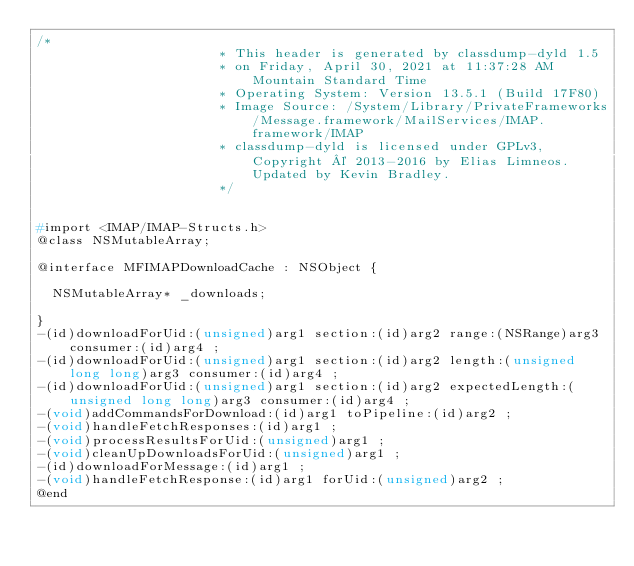<code> <loc_0><loc_0><loc_500><loc_500><_C_>/*
                       * This header is generated by classdump-dyld 1.5
                       * on Friday, April 30, 2021 at 11:37:28 AM Mountain Standard Time
                       * Operating System: Version 13.5.1 (Build 17F80)
                       * Image Source: /System/Library/PrivateFrameworks/Message.framework/MailServices/IMAP.framework/IMAP
                       * classdump-dyld is licensed under GPLv3, Copyright © 2013-2016 by Elias Limneos. Updated by Kevin Bradley.
                       */


#import <IMAP/IMAP-Structs.h>
@class NSMutableArray;

@interface MFIMAPDownloadCache : NSObject {

	NSMutableArray* _downloads;

}
-(id)downloadForUid:(unsigned)arg1 section:(id)arg2 range:(NSRange)arg3 consumer:(id)arg4 ;
-(id)downloadForUid:(unsigned)arg1 section:(id)arg2 length:(unsigned long long)arg3 consumer:(id)arg4 ;
-(id)downloadForUid:(unsigned)arg1 section:(id)arg2 expectedLength:(unsigned long long)arg3 consumer:(id)arg4 ;
-(void)addCommandsForDownload:(id)arg1 toPipeline:(id)arg2 ;
-(void)handleFetchResponses:(id)arg1 ;
-(void)processResultsForUid:(unsigned)arg1 ;
-(void)cleanUpDownloadsForUid:(unsigned)arg1 ;
-(id)downloadForMessage:(id)arg1 ;
-(void)handleFetchResponse:(id)arg1 forUid:(unsigned)arg2 ;
@end

</code> 